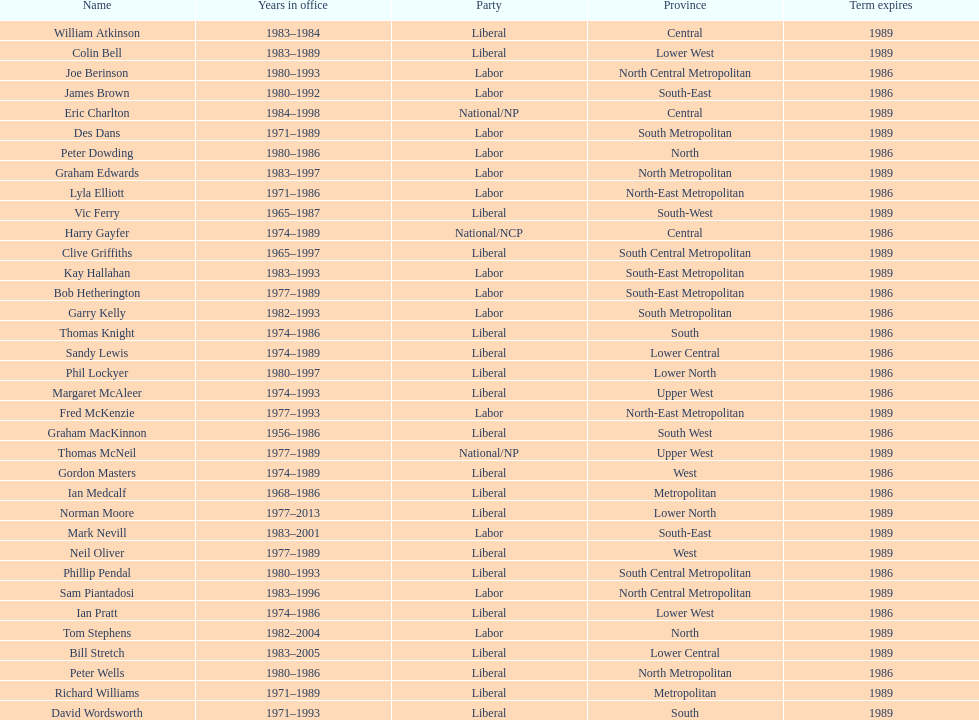Hame the last member listed whose last name begins with "p". Ian Pratt. 